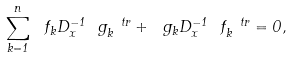Convert formula to latex. <formula><loc_0><loc_0><loc_500><loc_500>\sum _ { k = 1 } ^ { n } \ f _ { k } D _ { x } ^ { - 1 } \ g _ { k } ^ { \ t r } + \ g _ { k } D _ { x } ^ { - 1 } \ f _ { k } ^ { \ t r } = 0 ,</formula> 